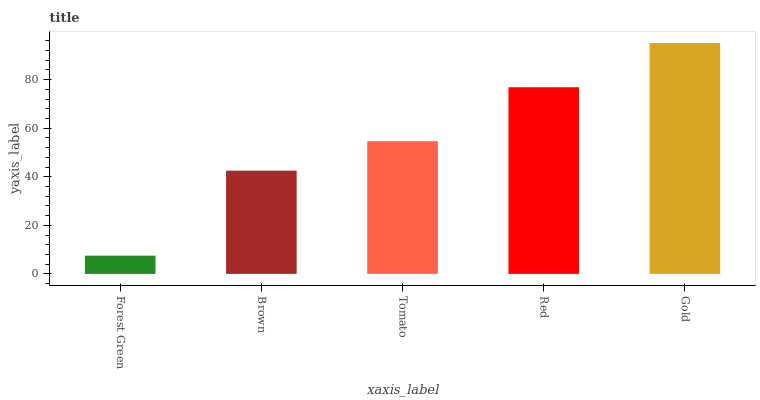Is Forest Green the minimum?
Answer yes or no. Yes. Is Gold the maximum?
Answer yes or no. Yes. Is Brown the minimum?
Answer yes or no. No. Is Brown the maximum?
Answer yes or no. No. Is Brown greater than Forest Green?
Answer yes or no. Yes. Is Forest Green less than Brown?
Answer yes or no. Yes. Is Forest Green greater than Brown?
Answer yes or no. No. Is Brown less than Forest Green?
Answer yes or no. No. Is Tomato the high median?
Answer yes or no. Yes. Is Tomato the low median?
Answer yes or no. Yes. Is Gold the high median?
Answer yes or no. No. Is Red the low median?
Answer yes or no. No. 